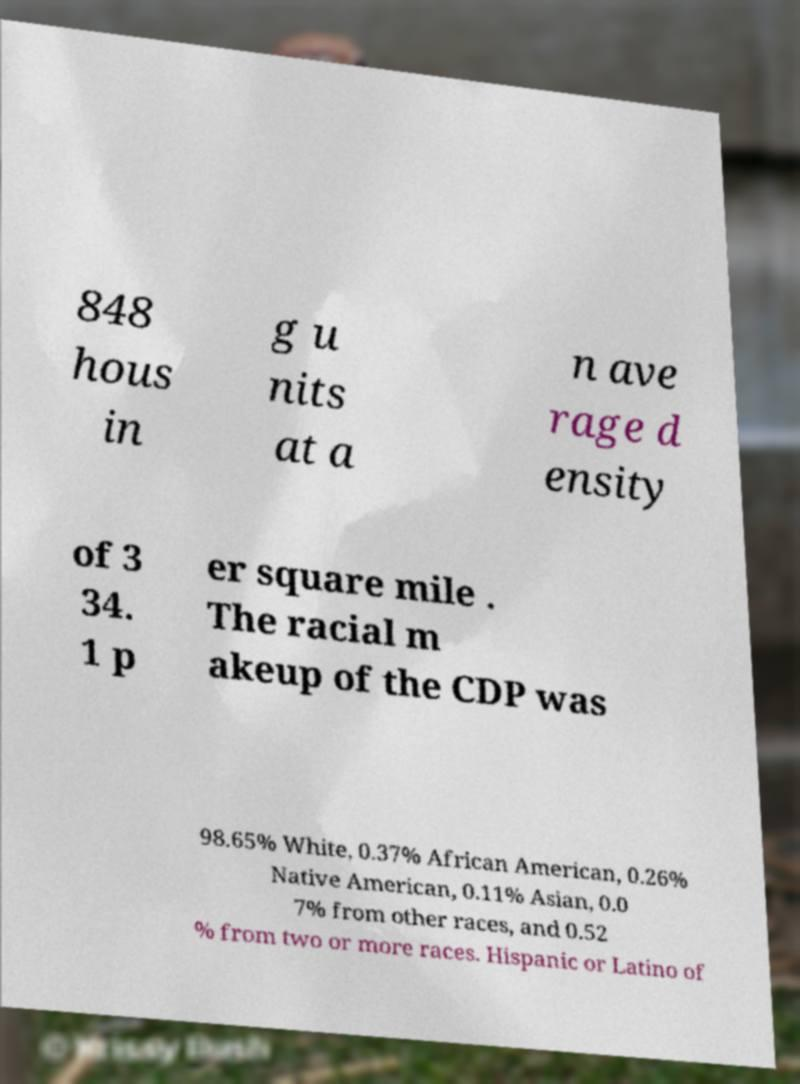Please identify and transcribe the text found in this image. 848 hous in g u nits at a n ave rage d ensity of 3 34. 1 p er square mile . The racial m akeup of the CDP was 98.65% White, 0.37% African American, 0.26% Native American, 0.11% Asian, 0.0 7% from other races, and 0.52 % from two or more races. Hispanic or Latino of 